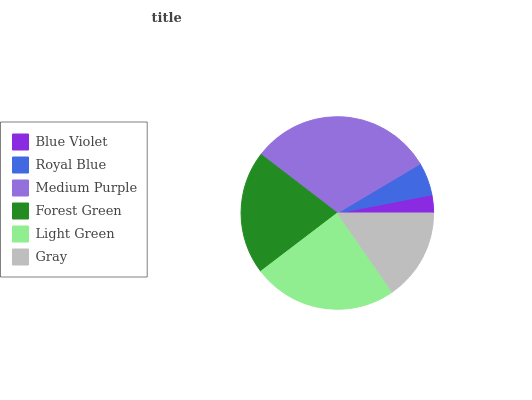Is Blue Violet the minimum?
Answer yes or no. Yes. Is Medium Purple the maximum?
Answer yes or no. Yes. Is Royal Blue the minimum?
Answer yes or no. No. Is Royal Blue the maximum?
Answer yes or no. No. Is Royal Blue greater than Blue Violet?
Answer yes or no. Yes. Is Blue Violet less than Royal Blue?
Answer yes or no. Yes. Is Blue Violet greater than Royal Blue?
Answer yes or no. No. Is Royal Blue less than Blue Violet?
Answer yes or no. No. Is Forest Green the high median?
Answer yes or no. Yes. Is Gray the low median?
Answer yes or no. Yes. Is Gray the high median?
Answer yes or no. No. Is Forest Green the low median?
Answer yes or no. No. 